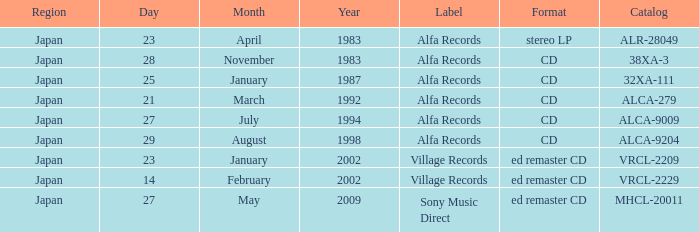Which region is identified as 38xa-3 in the catalog? Japan. 